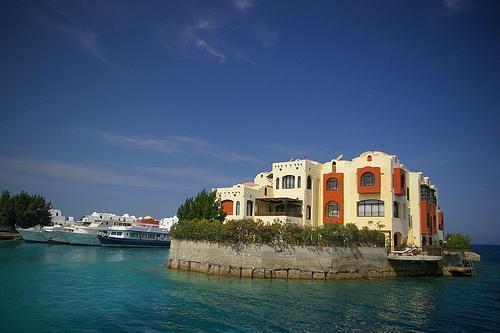What is the house near?
Pick the correct solution from the four options below to address the question.
Options: Baby, cat, water, dog. Water. 